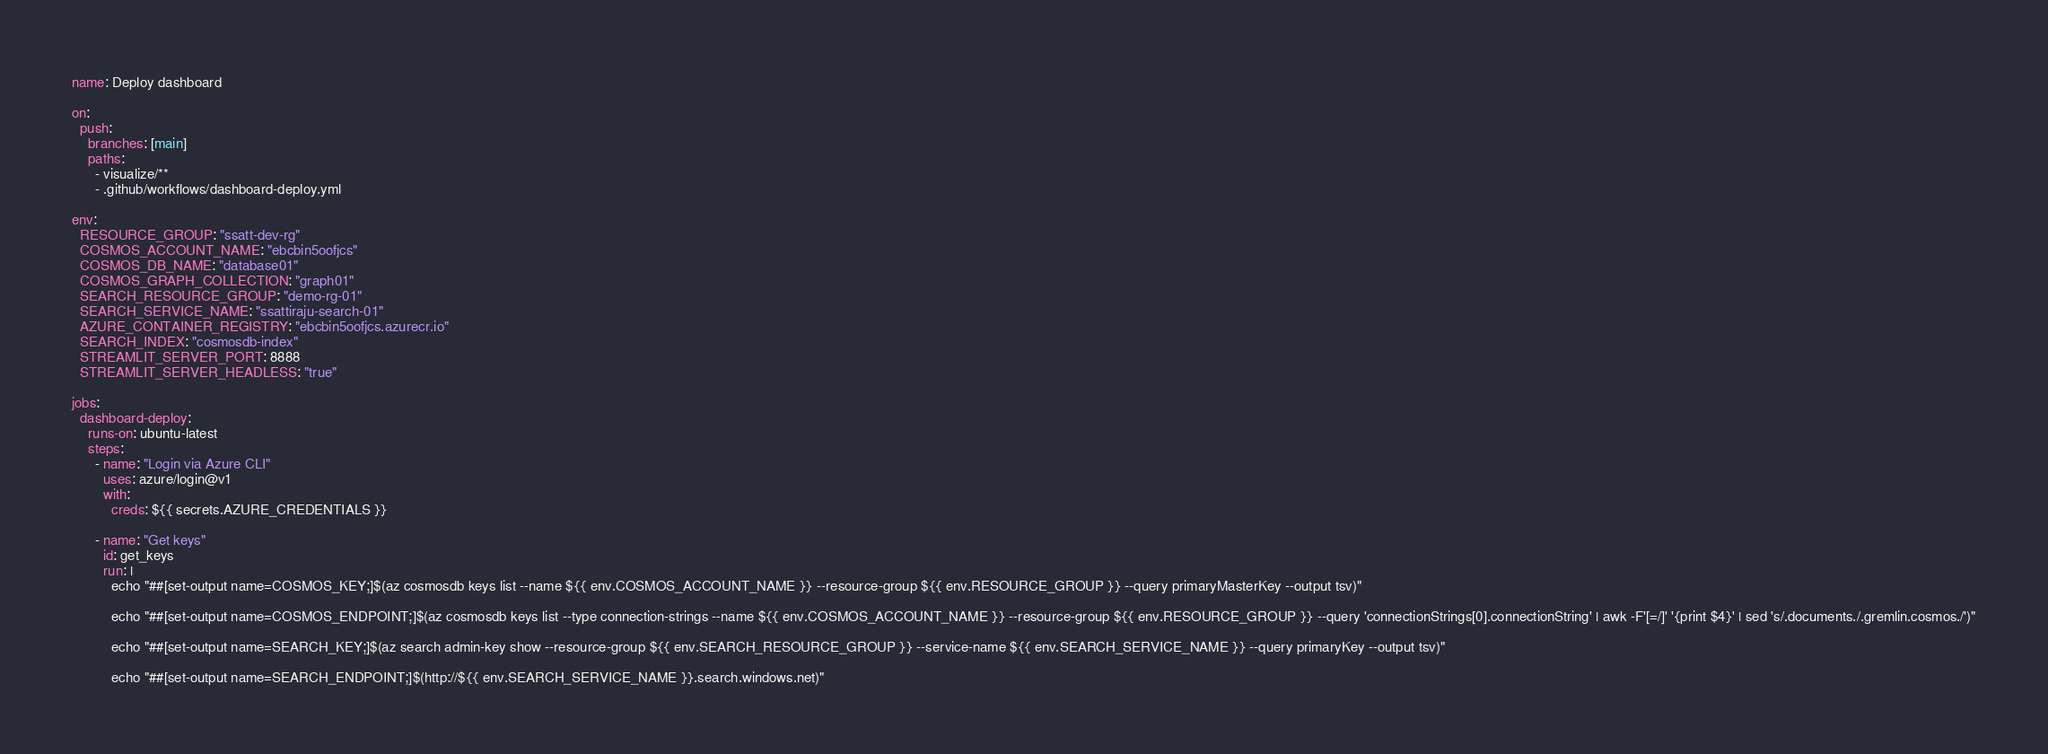Convert code to text. <code><loc_0><loc_0><loc_500><loc_500><_YAML_>name: Deploy dashboard

on:
  push:
    branches: [main]
    paths:
      - visualize/**
      - .github/workflows/dashboard-deploy.yml

env:
  RESOURCE_GROUP: "ssatt-dev-rg"
  COSMOS_ACCOUNT_NAME: "ebcbin5oofjcs"
  COSMOS_DB_NAME: "database01"
  COSMOS_GRAPH_COLLECTION: "graph01"
  SEARCH_RESOURCE_GROUP: "demo-rg-01"
  SEARCH_SERVICE_NAME: "ssattiraju-search-01"
  AZURE_CONTAINER_REGISTRY: "ebcbin5oofjcs.azurecr.io"
  SEARCH_INDEX: "cosmosdb-index"
  STREAMLIT_SERVER_PORT: 8888
  STREAMLIT_SERVER_HEADLESS: "true"

jobs:
  dashboard-deploy:
    runs-on: ubuntu-latest
    steps:
      - name: "Login via Azure CLI"
        uses: azure/login@v1
        with:
          creds: ${{ secrets.AZURE_CREDENTIALS }}

      - name: "Get keys"
        id: get_keys
        run: |
          echo "##[set-output name=COSMOS_KEY;]$(az cosmosdb keys list --name ${{ env.COSMOS_ACCOUNT_NAME }} --resource-group ${{ env.RESOURCE_GROUP }} --query primaryMasterKey --output tsv)"

          echo "##[set-output name=COSMOS_ENDPOINT;]$(az cosmosdb keys list --type connection-strings --name ${{ env.COSMOS_ACCOUNT_NAME }} --resource-group ${{ env.RESOURCE_GROUP }} --query 'connectionStrings[0].connectionString' | awk -F'[=/]' '{print $4}' | sed 's/.documents./.gremlin.cosmos./')"

          echo "##[set-output name=SEARCH_KEY;]$(az search admin-key show --resource-group ${{ env.SEARCH_RESOURCE_GROUP }} --service-name ${{ env.SEARCH_SERVICE_NAME }} --query primaryKey --output tsv)"

          echo "##[set-output name=SEARCH_ENDPOINT;]$(http://${{ env.SEARCH_SERVICE_NAME }}.search.windows.net)"
</code> 